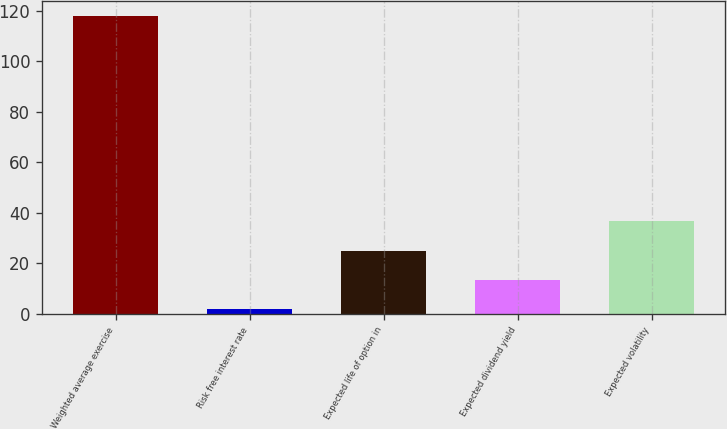<chart> <loc_0><loc_0><loc_500><loc_500><bar_chart><fcel>Weighted average exercise<fcel>Risk free interest rate<fcel>Expected life of option in<fcel>Expected dividend yield<fcel>Expected volatility<nl><fcel>118.02<fcel>1.9<fcel>25.12<fcel>13.51<fcel>36.73<nl></chart> 